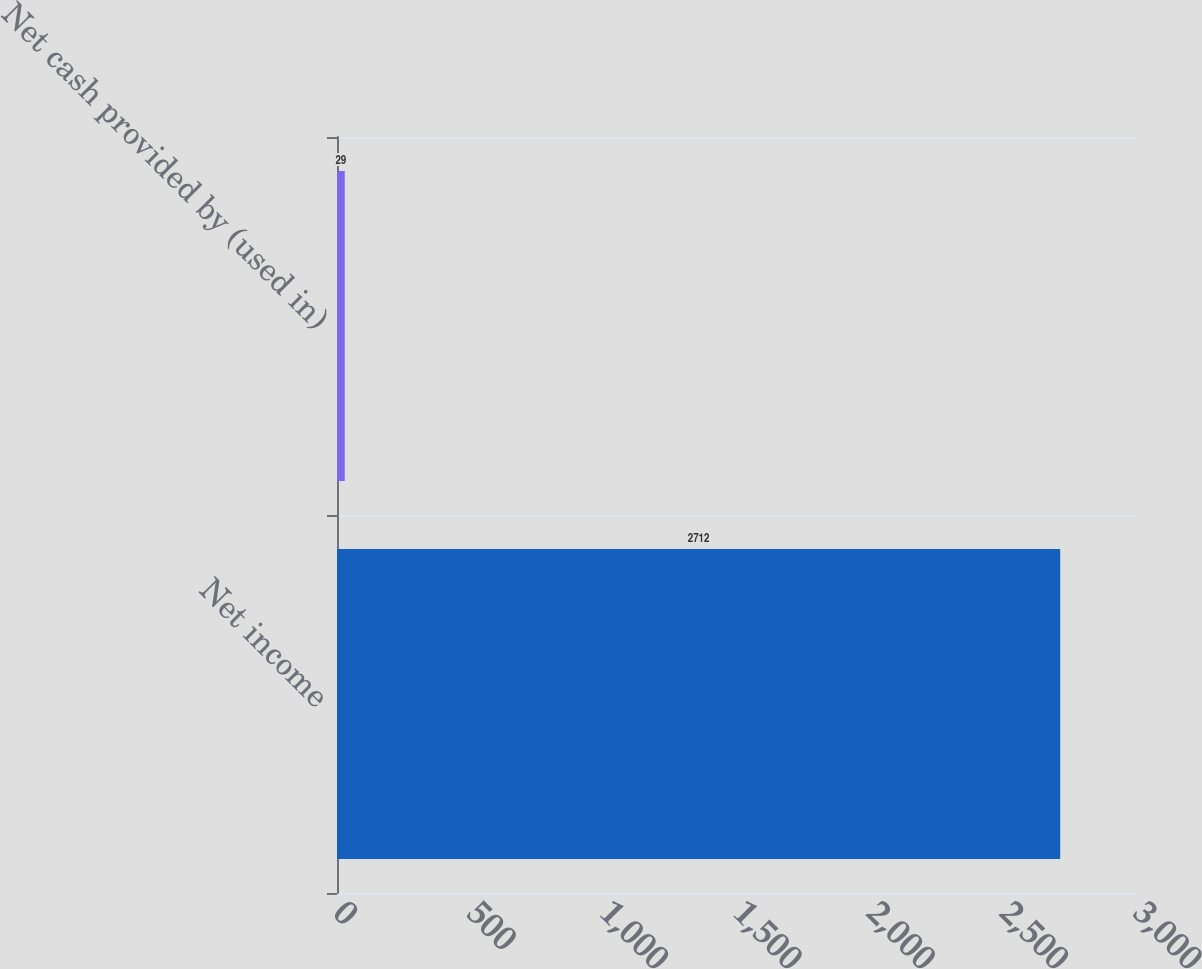Convert chart. <chart><loc_0><loc_0><loc_500><loc_500><bar_chart><fcel>Net income<fcel>Net cash provided by (used in)<nl><fcel>2712<fcel>29<nl></chart> 